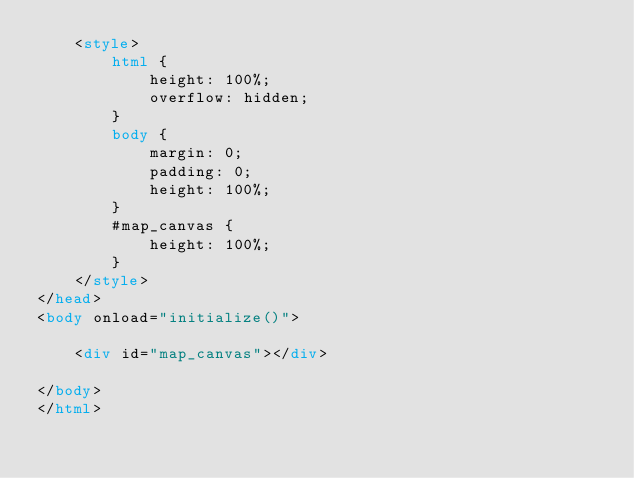<code> <loc_0><loc_0><loc_500><loc_500><_HTML_>    <style>
        html {
            height: 100%;
            overflow: hidden;
        }
        body {
            margin: 0;
            padding: 0;
            height: 100%;
        }
        #map_canvas { 
            height: 100%;
        }    
    </style>
</head>
<body onload="initialize()">

    <div id="map_canvas"></div>
    
</body>
</html></code> 